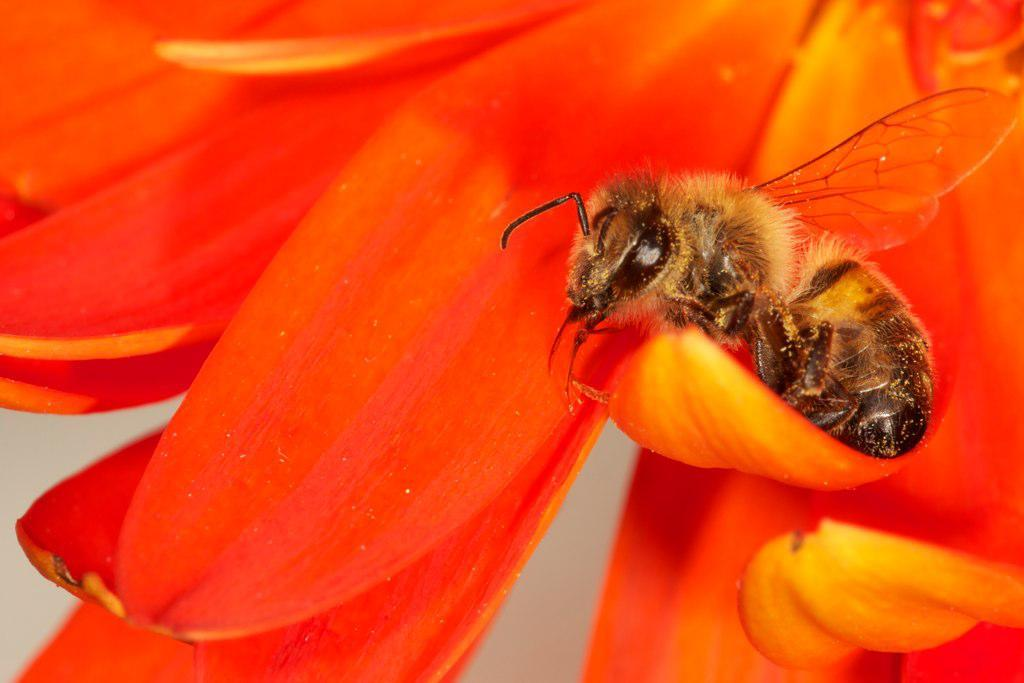What is present in the image? There is a bee in the image. Where is the bee located? The bee is on a flower. Can you describe the setting of the image? The image may have been taken in a garden. What process does the bee use to grant wishes in the image? There is no indication in the image that the bee is granting wishes or using any process to do so. 